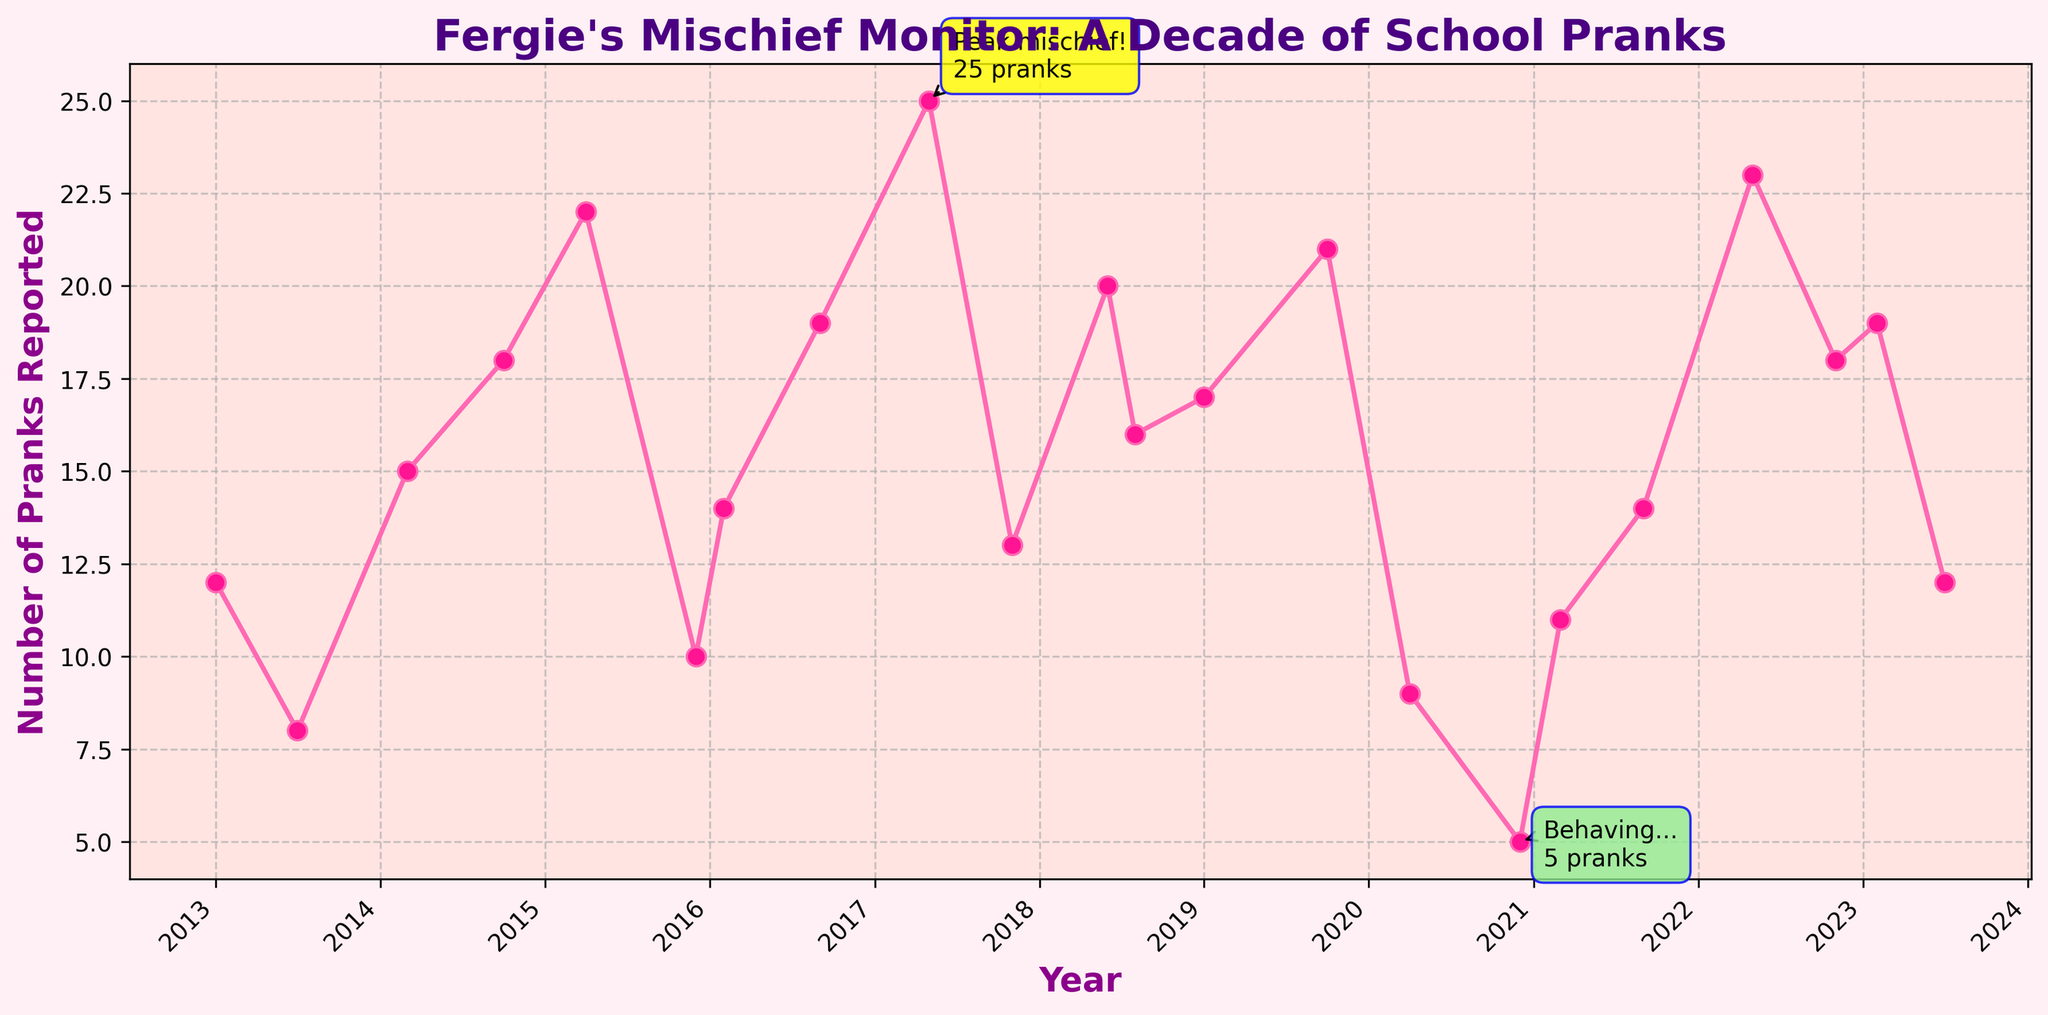How many pranks were reported in the peak year? Identify the data point with the maximum number of pranks reported. The highest value marked on the plot is 25 pranks in May 2017.
Answer: 25 During which month and year was the lowest number of pranks reported? Locate the data point with the minimum value. The plot annotates the lowest value with 5 pranks in December 2020.
Answer: December 2020 What is the difference in the number of pranks reported between the highest and lowest points? Identify the peak pranks (25) and the lowest pranks (5) from the plot. Subtract the lowest number from the highest number: 25 - 5 = 20
Answer: 20 Which year had the highest average number of pranks reported? Calculate the average for each year by summing the pranks reported for that year and dividing by the number of months with data points. Comparing the averages, 2017 stands out with the highest average.
Answer: 2017 How many pranks were reported in the months of March across different years? Add up the pranks reported in March 2014 (15) and March 2021 (11), using the data provided. 15 + 11 = 26
Answer: 26 Which season of the year tends to have more pranks: Spring (March to May) or Summer (June to August)? Observe and compare the values in the Spring months (March 2014: 15, April 2015: 22, May 2017: 25, March 2021: 11, May 2022: 23) and Summer months (June 2018: 20, July 2013: 8, August 2018: 16, July 2023: 12). Spring months sum up to 96, while Summer sums to 56. Hence, Spring has more pranks.
Answer: Spring What trend do you observe in the number of pranks reported over the years? Look at the plot line's overall direction. It shows fluctuations with periods of increase and decrease, but it does not show a clear consistent upward or downward trend throughout the decade.
Answer: Fluctuating Are there any months that repeatedly appear to have a high number of pranks reported? Scan the plot and note the months with higher values. Months like April (2015: 22), May (2017: 25, 2022: 23), and October (2014: 18, 2019: 21) tend to have higher numbers.
Answer: April, May, October Is there a significant visual difference in the number of pranks reported before and after 2020? Compare the data points visually before and after the year 2020. Before 2020, the pranks are relatively high and frequent, while after 2020, the numbers appear slightly lower overall.
Answer: Yes 